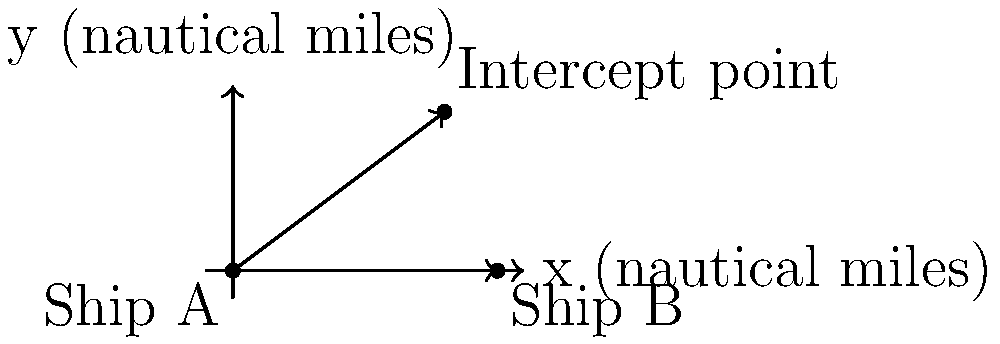Two ships are on intersecting courses in open waters. Ship A is located at the origin (0,0) and is traveling at 20 knots on a course of 30° relative to the positive x-axis. Ship B starts at position (10,0) and is traveling at 15 knots on a course of 135° relative to the positive x-axis. Using vector calculus, determine the time it will take for the ships to intercept each other and the coordinates of the interception point. Let's approach this step-by-step using vector calculus:

1) First, we need to express the velocities as vectors:
   Ship A: $\vec{v_A} = 20(\cos 30°, \sin 30°) = (17.32, 10)$ knots
   Ship B: $\vec{v_B} = 15(\cos 135°, \sin 135°) = (-10.61, 10.61)$ knots

2) The position vectors of the ships at time t can be expressed as:
   $\vec{r_A}(t) = (0,0) + t(17.32, 10)$
   $\vec{r_B}(t) = (10,0) + t(-10.61, 10.61)$

3) At the point of interception, these position vectors will be equal:
   $(0,0) + t(17.32, 10) = (10,0) + t(-10.61, 10.61)$

4) This gives us two equations:
   $17.32t = 10 - 10.61t$
   $10t = 10.61t$

5) From the second equation:
   $10t = 10.61t$
   $-0.61t = 0$
   $t = 0$ (trivial solution) or the equation is always true

6) Using the first equation:
   $17.32t = 10 - 10.61t$
   $27.93t = 10$
   $t = 10/27.93 = 0.358$ hours (or about 21.5 minutes)

7) To find the interception point, we can substitute this t back into either position vector:
   $\vec{r_A}(0.358) = (0,0) + 0.358(17.32, 10) = (6.20, 3.58)$

Therefore, the interception point is approximately (6.20, 3.58) nautical miles from the origin.
Answer: Time to intercept: 0.358 hours. Interception point: (6.20, 3.58) nautical miles. 